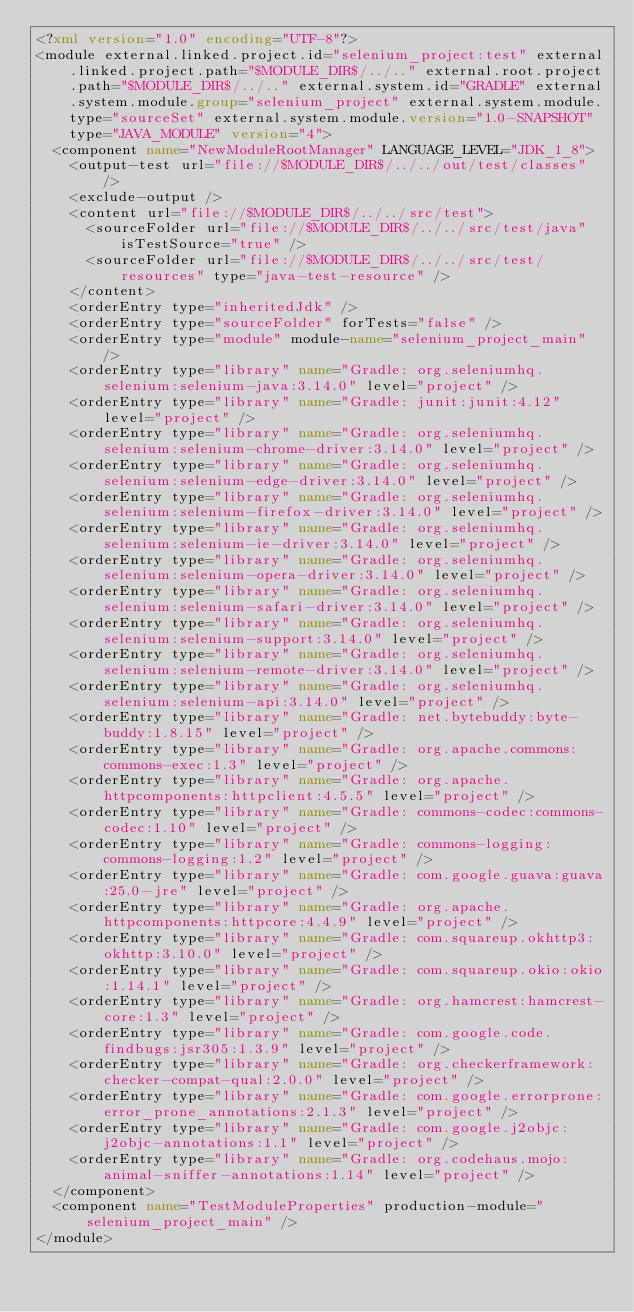<code> <loc_0><loc_0><loc_500><loc_500><_XML_><?xml version="1.0" encoding="UTF-8"?>
<module external.linked.project.id="selenium_project:test" external.linked.project.path="$MODULE_DIR$/../.." external.root.project.path="$MODULE_DIR$/../.." external.system.id="GRADLE" external.system.module.group="selenium_project" external.system.module.type="sourceSet" external.system.module.version="1.0-SNAPSHOT" type="JAVA_MODULE" version="4">
  <component name="NewModuleRootManager" LANGUAGE_LEVEL="JDK_1_8">
    <output-test url="file://$MODULE_DIR$/../../out/test/classes" />
    <exclude-output />
    <content url="file://$MODULE_DIR$/../../src/test">
      <sourceFolder url="file://$MODULE_DIR$/../../src/test/java" isTestSource="true" />
      <sourceFolder url="file://$MODULE_DIR$/../../src/test/resources" type="java-test-resource" />
    </content>
    <orderEntry type="inheritedJdk" />
    <orderEntry type="sourceFolder" forTests="false" />
    <orderEntry type="module" module-name="selenium_project_main" />
    <orderEntry type="library" name="Gradle: org.seleniumhq.selenium:selenium-java:3.14.0" level="project" />
    <orderEntry type="library" name="Gradle: junit:junit:4.12" level="project" />
    <orderEntry type="library" name="Gradle: org.seleniumhq.selenium:selenium-chrome-driver:3.14.0" level="project" />
    <orderEntry type="library" name="Gradle: org.seleniumhq.selenium:selenium-edge-driver:3.14.0" level="project" />
    <orderEntry type="library" name="Gradle: org.seleniumhq.selenium:selenium-firefox-driver:3.14.0" level="project" />
    <orderEntry type="library" name="Gradle: org.seleniumhq.selenium:selenium-ie-driver:3.14.0" level="project" />
    <orderEntry type="library" name="Gradle: org.seleniumhq.selenium:selenium-opera-driver:3.14.0" level="project" />
    <orderEntry type="library" name="Gradle: org.seleniumhq.selenium:selenium-safari-driver:3.14.0" level="project" />
    <orderEntry type="library" name="Gradle: org.seleniumhq.selenium:selenium-support:3.14.0" level="project" />
    <orderEntry type="library" name="Gradle: org.seleniumhq.selenium:selenium-remote-driver:3.14.0" level="project" />
    <orderEntry type="library" name="Gradle: org.seleniumhq.selenium:selenium-api:3.14.0" level="project" />
    <orderEntry type="library" name="Gradle: net.bytebuddy:byte-buddy:1.8.15" level="project" />
    <orderEntry type="library" name="Gradle: org.apache.commons:commons-exec:1.3" level="project" />
    <orderEntry type="library" name="Gradle: org.apache.httpcomponents:httpclient:4.5.5" level="project" />
    <orderEntry type="library" name="Gradle: commons-codec:commons-codec:1.10" level="project" />
    <orderEntry type="library" name="Gradle: commons-logging:commons-logging:1.2" level="project" />
    <orderEntry type="library" name="Gradle: com.google.guava:guava:25.0-jre" level="project" />
    <orderEntry type="library" name="Gradle: org.apache.httpcomponents:httpcore:4.4.9" level="project" />
    <orderEntry type="library" name="Gradle: com.squareup.okhttp3:okhttp:3.10.0" level="project" />
    <orderEntry type="library" name="Gradle: com.squareup.okio:okio:1.14.1" level="project" />
    <orderEntry type="library" name="Gradle: org.hamcrest:hamcrest-core:1.3" level="project" />
    <orderEntry type="library" name="Gradle: com.google.code.findbugs:jsr305:1.3.9" level="project" />
    <orderEntry type="library" name="Gradle: org.checkerframework:checker-compat-qual:2.0.0" level="project" />
    <orderEntry type="library" name="Gradle: com.google.errorprone:error_prone_annotations:2.1.3" level="project" />
    <orderEntry type="library" name="Gradle: com.google.j2objc:j2objc-annotations:1.1" level="project" />
    <orderEntry type="library" name="Gradle: org.codehaus.mojo:animal-sniffer-annotations:1.14" level="project" />
  </component>
  <component name="TestModuleProperties" production-module="selenium_project_main" />
</module></code> 